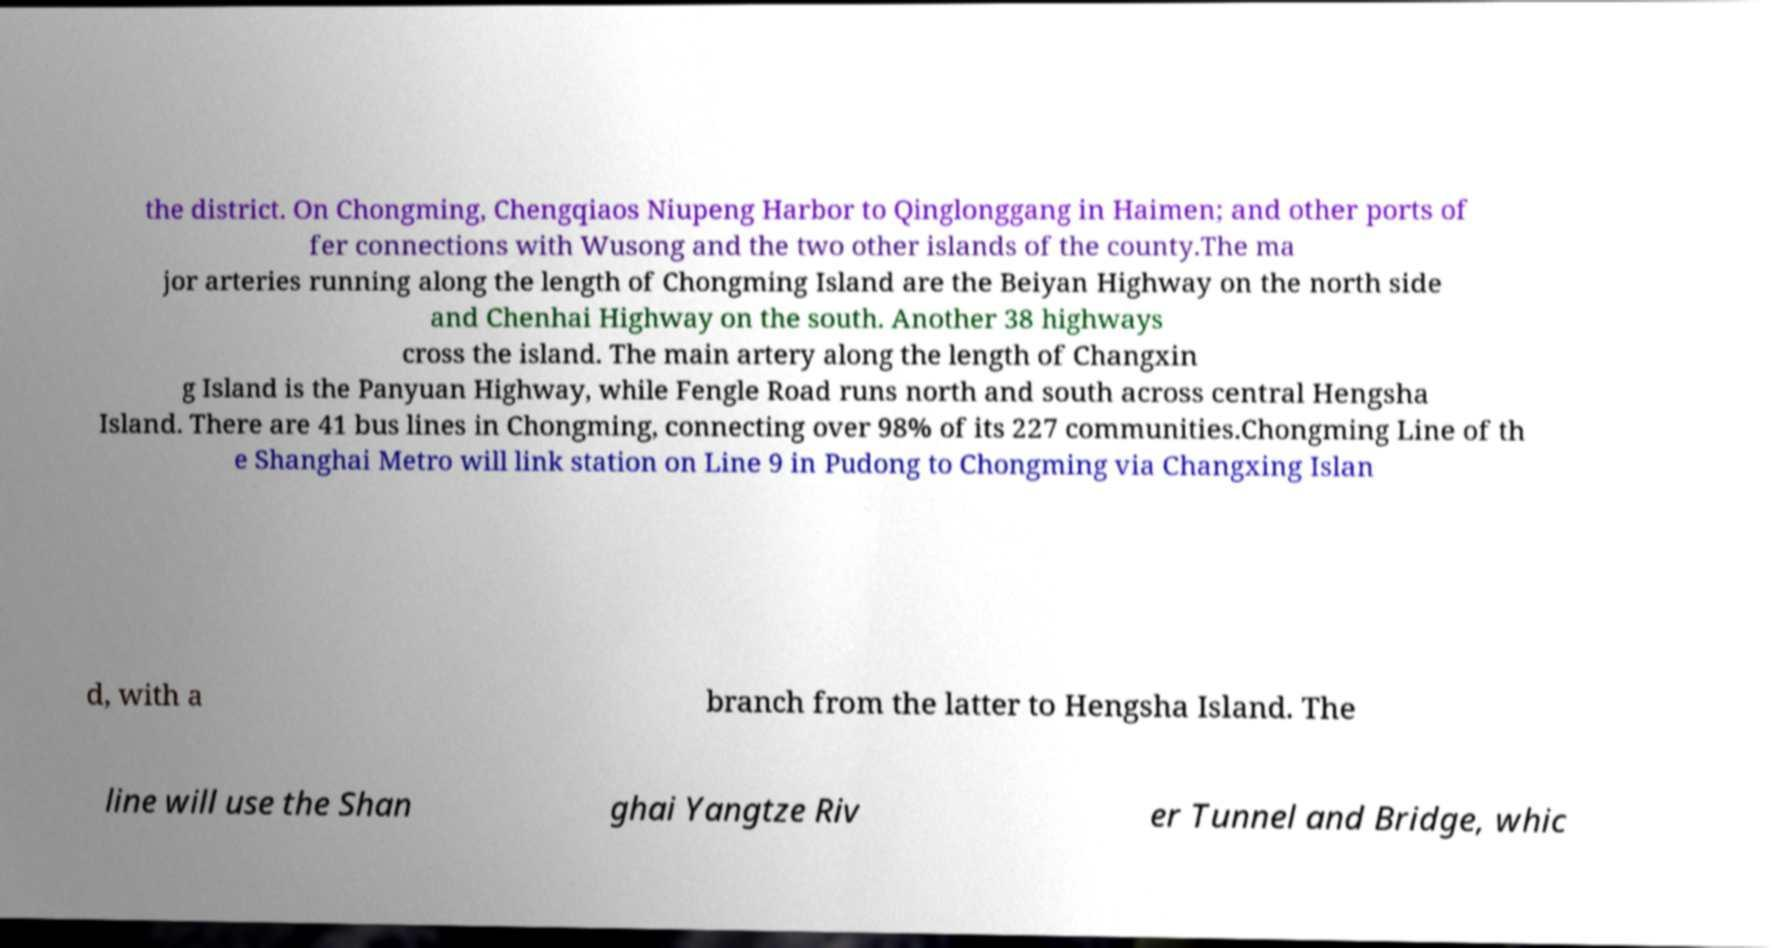Could you assist in decoding the text presented in this image and type it out clearly? the district. On Chongming, Chengqiaos Niupeng Harbor to Qinglonggang in Haimen; and other ports of fer connections with Wusong and the two other islands of the county.The ma jor arteries running along the length of Chongming Island are the Beiyan Highway on the north side and Chenhai Highway on the south. Another 38 highways cross the island. The main artery along the length of Changxin g Island is the Panyuan Highway, while Fengle Road runs north and south across central Hengsha Island. There are 41 bus lines in Chongming, connecting over 98% of its 227 communities.Chongming Line of th e Shanghai Metro will link station on Line 9 in Pudong to Chongming via Changxing Islan d, with a branch from the latter to Hengsha Island. The line will use the Shan ghai Yangtze Riv er Tunnel and Bridge, whic 